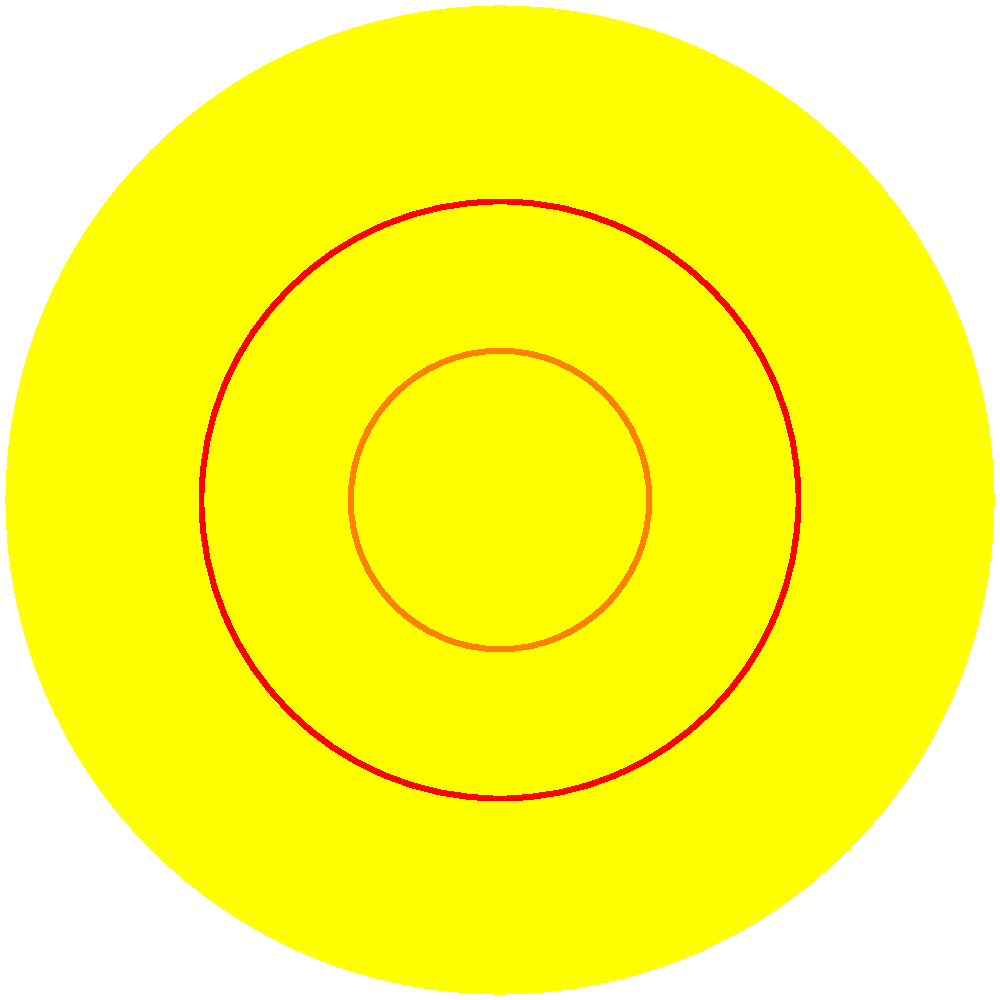Your older sibling is studying for an astronomy exam and asks you to help them understand the layers of the Sun. Which layer is responsible for transferring energy through radiation and is located between the core and the convective zone? To answer this question, let's break down the layers of the Sun from the inside out:

1. Core: This is the innermost layer where nuclear fusion occurs, generating the Sun's energy.

2. Radiative Zone: This is the layer immediately surrounding the core. In this zone, energy is transferred outward through radiation. Photons bounce around in this dense region, slowly making their way outward.

3. Convective Zone: This layer is above the radiative zone. Here, energy is transferred through convection currents, with hot plasma rising and cooler plasma sinking.

4. Photosphere: This is the visible surface of the Sun, where light can finally escape into space.

The question asks about the layer between the core and the convective zone that transfers energy through radiation. Based on our breakdown, this clearly refers to the radiative zone.

As a loyal younger sibling, you can confidently share this information with your older sibling to help them prepare for their exam.
Answer: Radiative Zone 